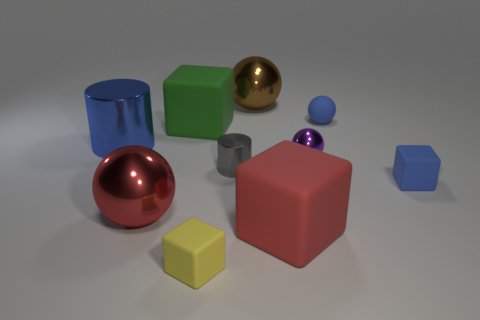Subtract 2 balls. How many balls are left? 2 Subtract all brown shiny spheres. How many spheres are left? 3 Subtract all green spheres. Subtract all blue cylinders. How many spheres are left? 4 Subtract all cylinders. How many objects are left? 8 Subtract all purple cubes. Subtract all red objects. How many objects are left? 8 Add 8 blue metal objects. How many blue metal objects are left? 9 Add 8 big red matte cubes. How many big red matte cubes exist? 9 Subtract 0 purple cubes. How many objects are left? 10 